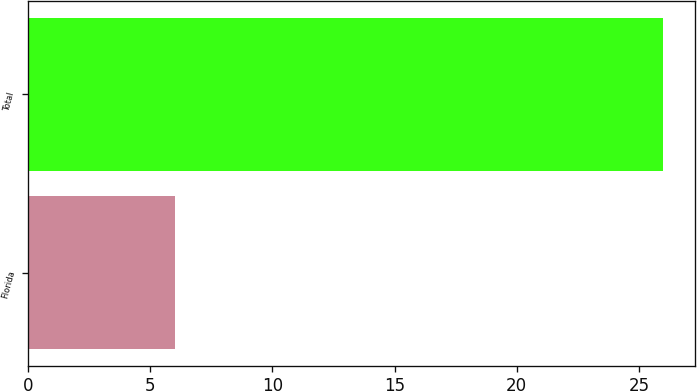Convert chart. <chart><loc_0><loc_0><loc_500><loc_500><bar_chart><fcel>Florida<fcel>Total<nl><fcel>6<fcel>26<nl></chart> 